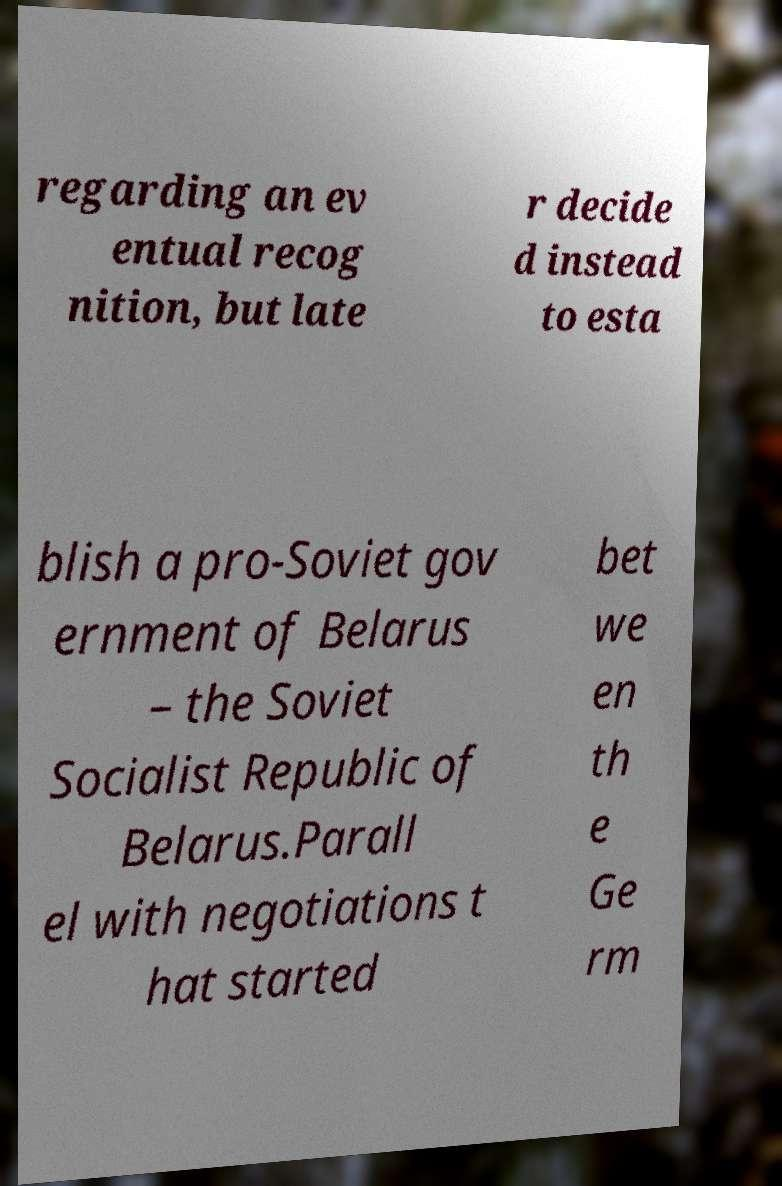Could you assist in decoding the text presented in this image and type it out clearly? regarding an ev entual recog nition, but late r decide d instead to esta blish a pro-Soviet gov ernment of Belarus – the Soviet Socialist Republic of Belarus.Parall el with negotiations t hat started bet we en th e Ge rm 